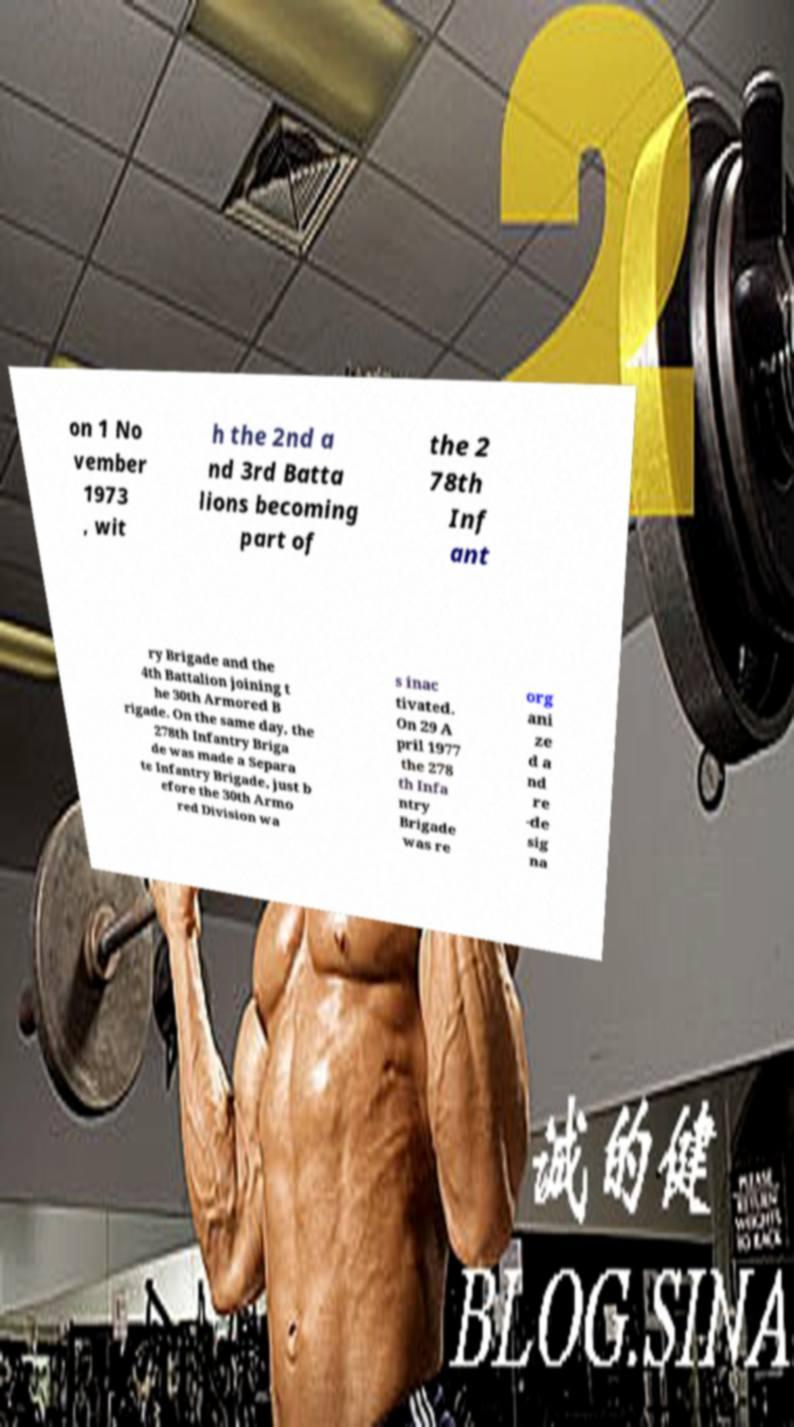Can you accurately transcribe the text from the provided image for me? on 1 No vember 1973 , wit h the 2nd a nd 3rd Batta lions becoming part of the 2 78th Inf ant ry Brigade and the 4th Battalion joining t he 30th Armored B rigade. On the same day, the 278th Infantry Briga de was made a Separa te Infantry Brigade, just b efore the 30th Armo red Division wa s inac tivated. On 29 A pril 1977 the 278 th Infa ntry Brigade was re org ani ze d a nd re -de sig na 